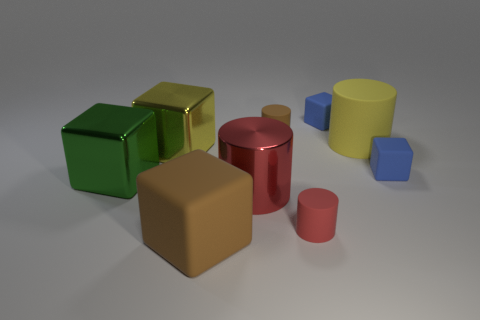Is there any other thing that is the same shape as the big red object?
Your answer should be compact. Yes. Is there a large matte object of the same color as the large matte cube?
Keep it short and to the point. No. Are the big block right of the yellow cube and the blue block behind the yellow rubber object made of the same material?
Your answer should be very brief. Yes. What is the color of the big rubber block?
Make the answer very short. Brown. How big is the brown matte thing that is behind the brown matte thing in front of the large rubber object to the right of the red metallic thing?
Offer a terse response. Small. How many other things are the same size as the yellow block?
Keep it short and to the point. 4. What number of small objects have the same material as the big yellow block?
Your answer should be compact. 0. What shape is the matte thing on the right side of the big yellow matte cylinder?
Your answer should be very brief. Cube. Is the small brown cylinder made of the same material as the tiny blue object on the left side of the yellow rubber object?
Keep it short and to the point. Yes. Are there any cyan cylinders?
Offer a terse response. No. 